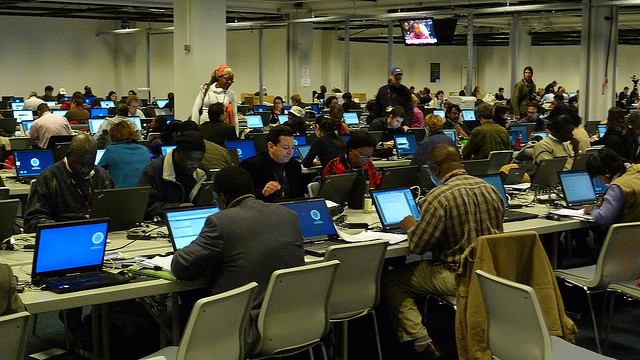How many chairs are there? Based on the image, there appears to be a large number of chairs accommodating multiple individuals, the precise count is challenging to establish due to the image's perspective. However, it seems that there are more than seven chairs visible in the scene. 